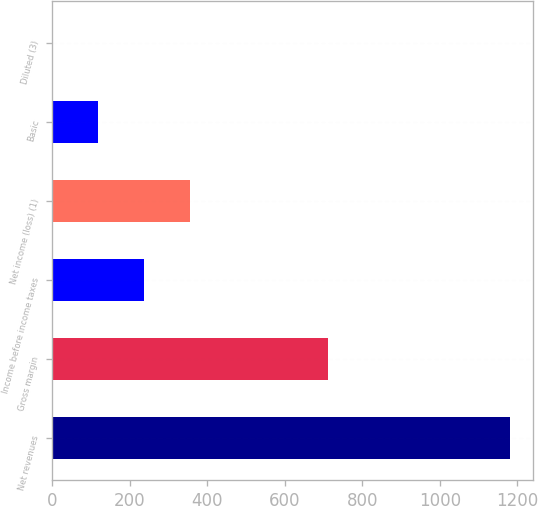<chart> <loc_0><loc_0><loc_500><loc_500><bar_chart><fcel>Net revenues<fcel>Gross margin<fcel>Income before income taxes<fcel>Net income (loss) (1)<fcel>Basic<fcel>Diluted (3)<nl><fcel>1181<fcel>710.9<fcel>236.65<fcel>354.7<fcel>118.6<fcel>0.55<nl></chart> 